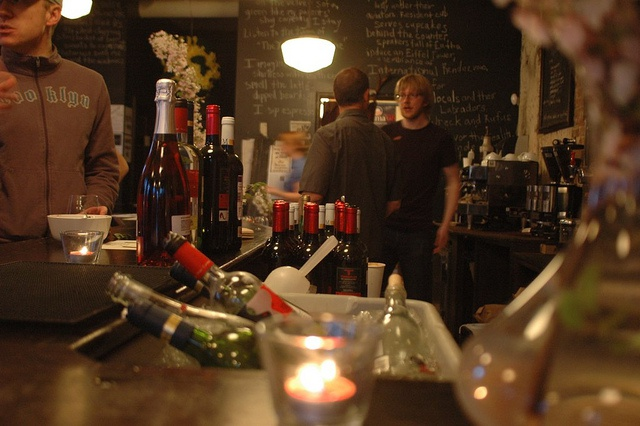Describe the objects in this image and their specific colors. I can see people in black, maroon, and brown tones, dining table in black, maroon, and olive tones, cup in black, maroon, gray, olive, and tan tones, people in black, maroon, and brown tones, and people in black, maroon, and brown tones in this image. 